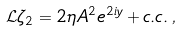<formula> <loc_0><loc_0><loc_500><loc_500>\mathcal { L } \zeta _ { 2 } = 2 \eta A ^ { 2 } e ^ { 2 i y } + c . c . \, ,</formula> 